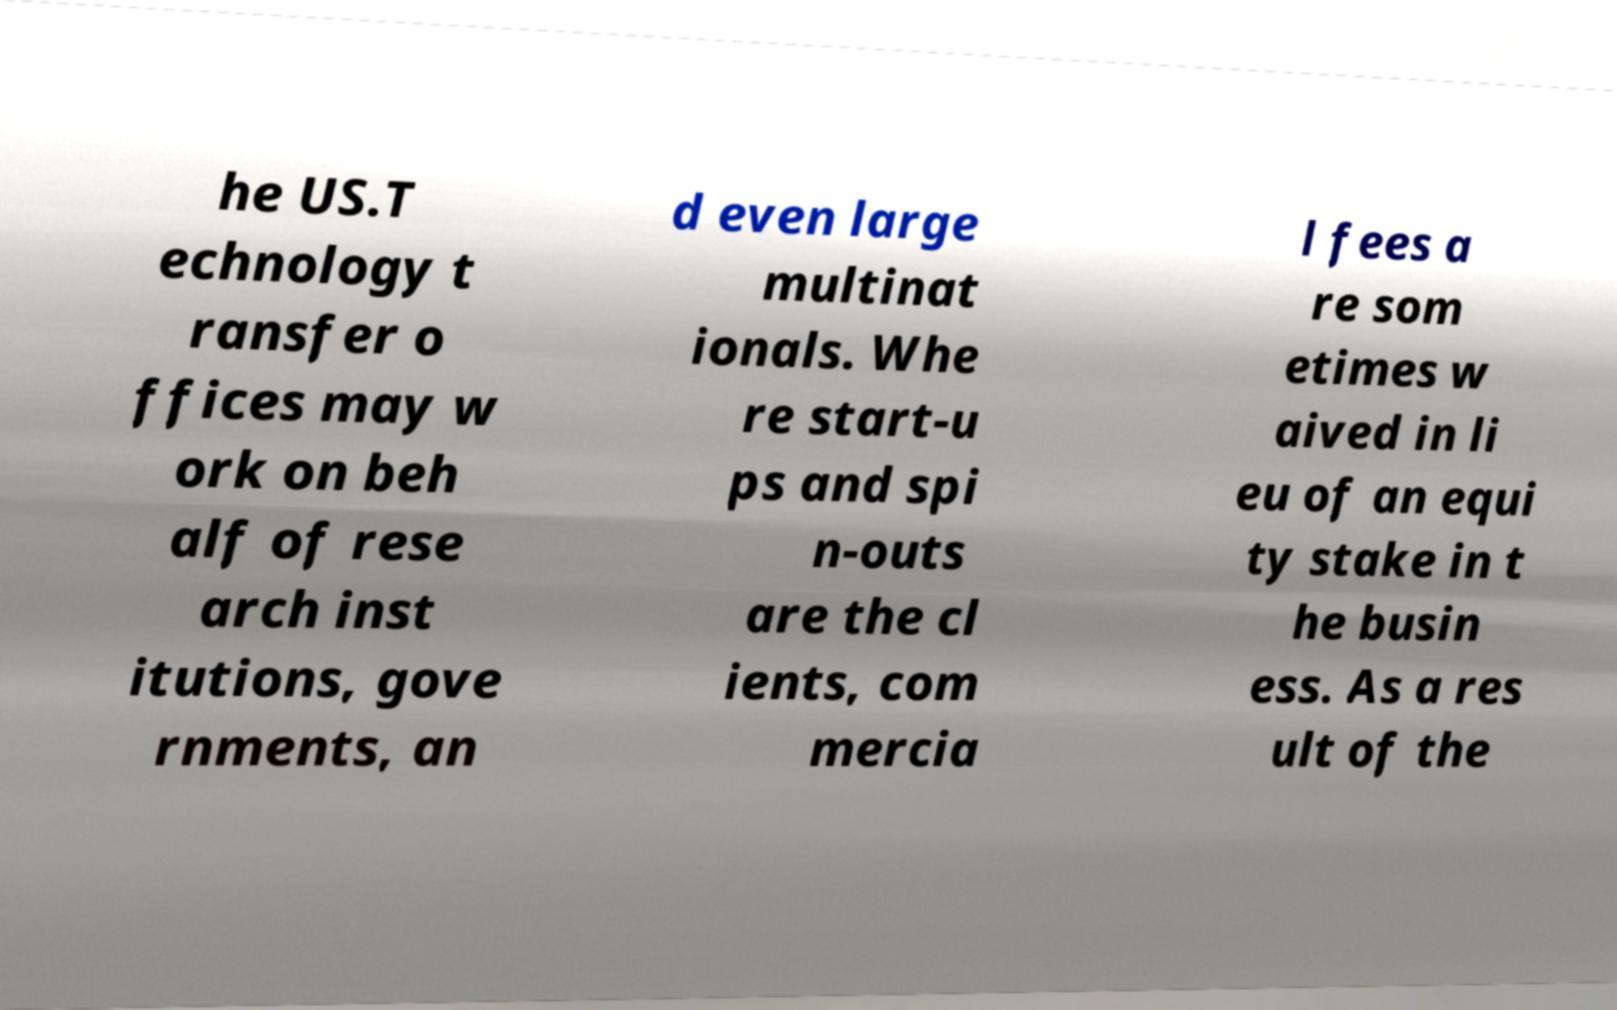Can you accurately transcribe the text from the provided image for me? he US.T echnology t ransfer o ffices may w ork on beh alf of rese arch inst itutions, gove rnments, an d even large multinat ionals. Whe re start-u ps and spi n-outs are the cl ients, com mercia l fees a re som etimes w aived in li eu of an equi ty stake in t he busin ess. As a res ult of the 